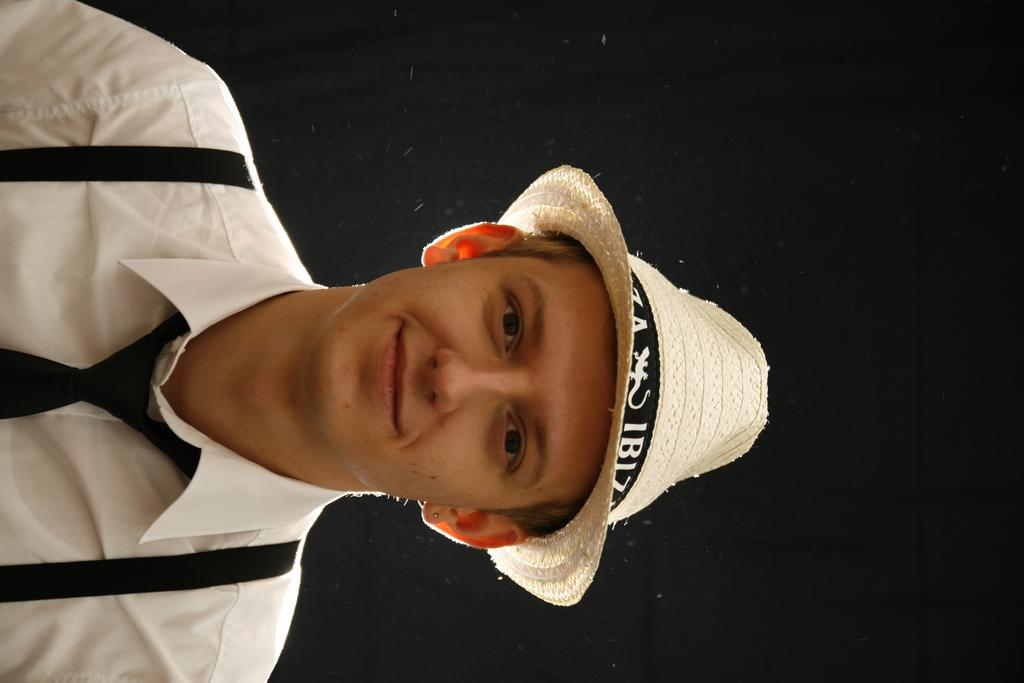Who is present in the image? There is a man in the image. What is the man doing in the image? The man is smiling in the image. What is the man wearing on his head? A: The man is wearing a cap in the image. What can be observed about the background of the image? The background of the image is dark. How many eyes does the farmer have in the image? There is no farmer present in the image, and therefore no eyes can be counted. What is the man's reaction to the shocking event in the image? There is no shocking event depicted in the image, and the man is simply smiling. 